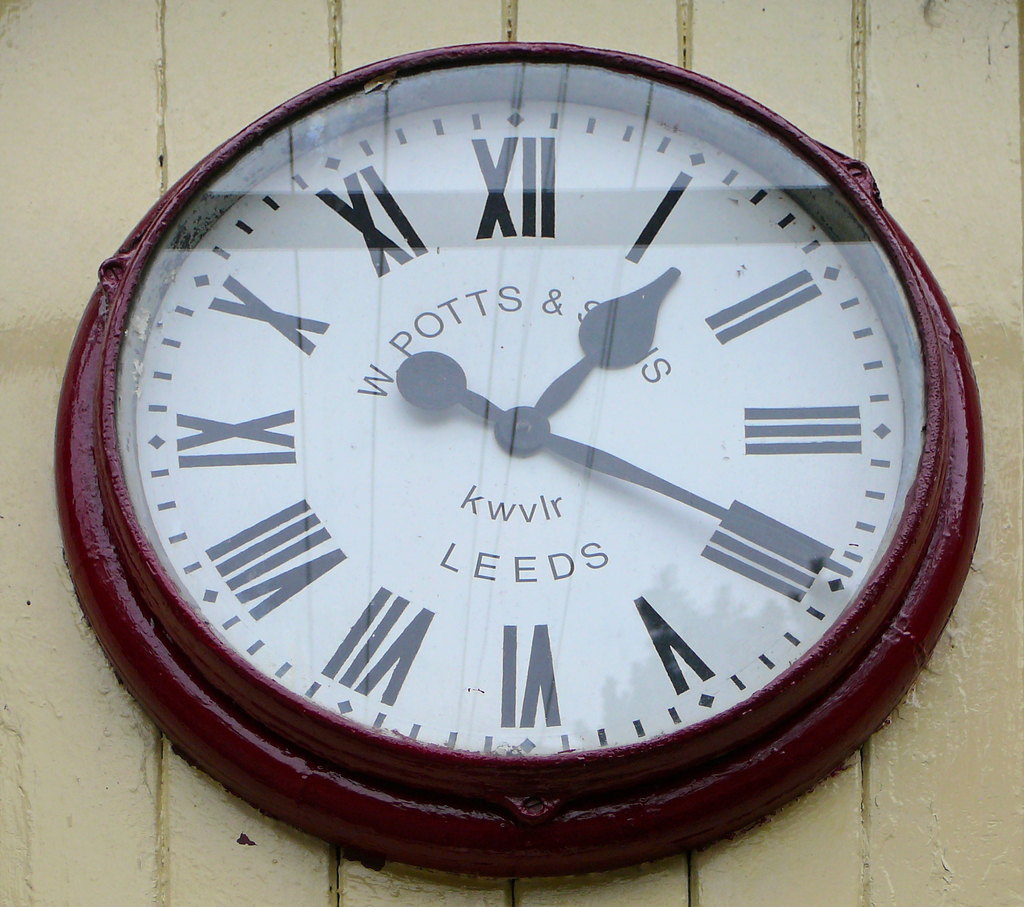What era does this clock's design suggest? The design of the clock, with its bold Roman numerals and classic analog hands, evokes a vintage feel, possibly dating back to the early to mid-20th century, reflecting a timeless elegance found in public timepieces of that era. 